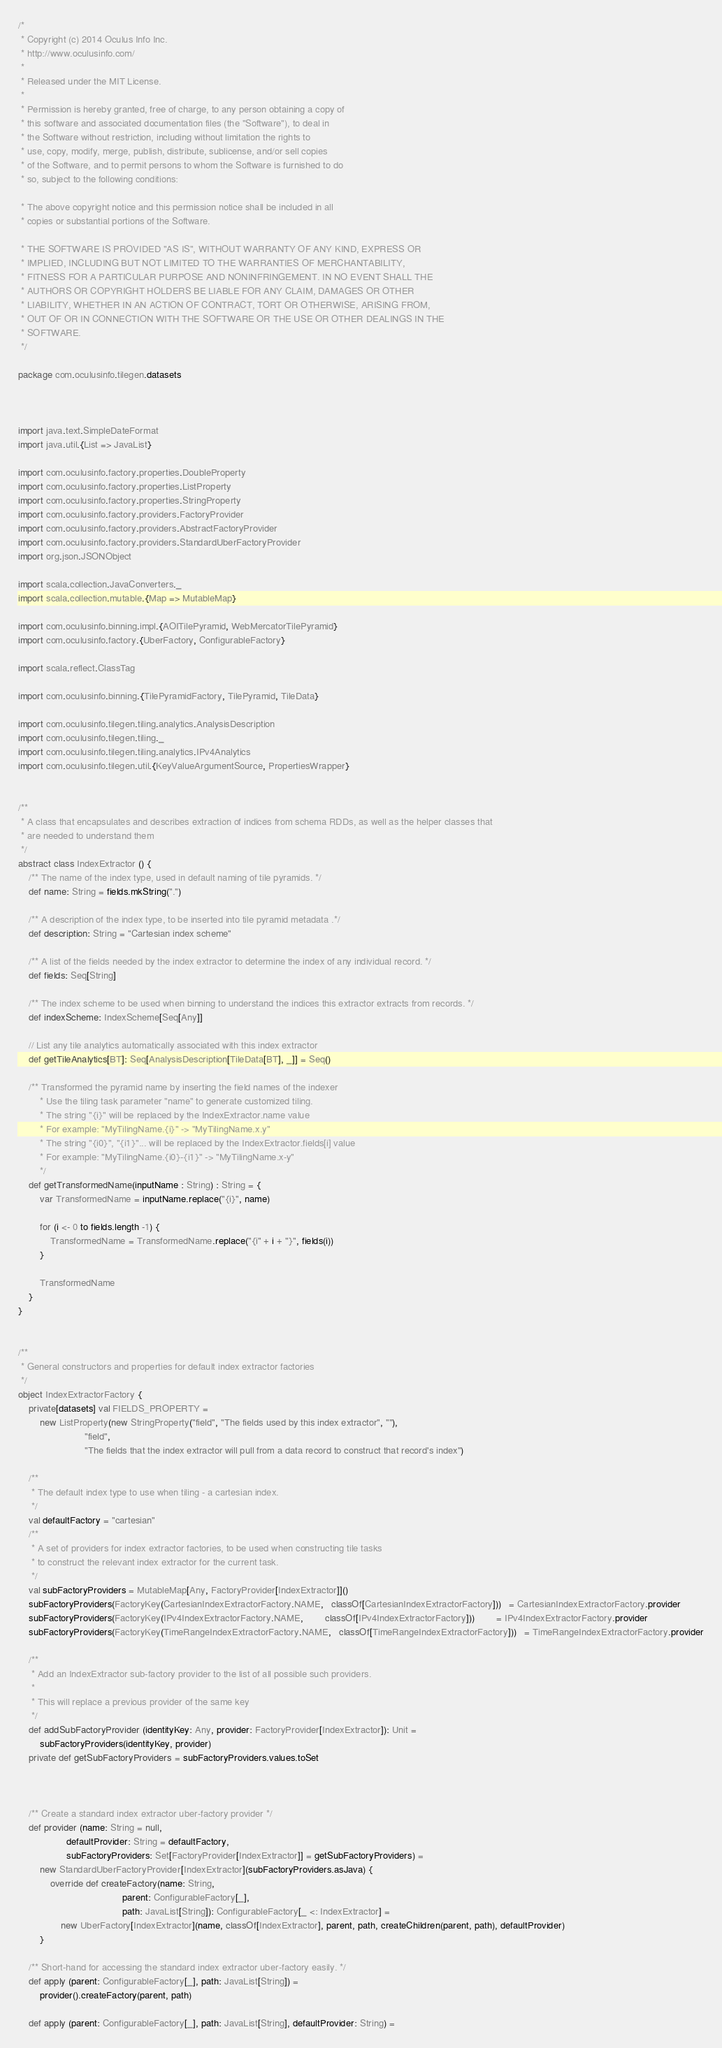Convert code to text. <code><loc_0><loc_0><loc_500><loc_500><_Scala_>/*
 * Copyright (c) 2014 Oculus Info Inc.
 * http://www.oculusinfo.com/
 *
 * Released under the MIT License.
 *
 * Permission is hereby granted, free of charge, to any person obtaining a copy of
 * this software and associated documentation files (the "Software"), to deal in
 * the Software without restriction, including without limitation the rights to
 * use, copy, modify, merge, publish, distribute, sublicense, and/or sell copies
 * of the Software, and to permit persons to whom the Software is furnished to do
 * so, subject to the following conditions:

 * The above copyright notice and this permission notice shall be included in all
 * copies or substantial portions of the Software.

 * THE SOFTWARE IS PROVIDED "AS IS", WITHOUT WARRANTY OF ANY KIND, EXPRESS OR
 * IMPLIED, INCLUDING BUT NOT LIMITED TO THE WARRANTIES OF MERCHANTABILITY,
 * FITNESS FOR A PARTICULAR PURPOSE AND NONINFRINGEMENT. IN NO EVENT SHALL THE
 * AUTHORS OR COPYRIGHT HOLDERS BE LIABLE FOR ANY CLAIM, DAMAGES OR OTHER
 * LIABILITY, WHETHER IN AN ACTION OF CONTRACT, TORT OR OTHERWISE, ARISING FROM,
 * OUT OF OR IN CONNECTION WITH THE SOFTWARE OR THE USE OR OTHER DEALINGS IN THE
 * SOFTWARE.
 */

package com.oculusinfo.tilegen.datasets



import java.text.SimpleDateFormat
import java.util.{List => JavaList}

import com.oculusinfo.factory.properties.DoubleProperty
import com.oculusinfo.factory.properties.ListProperty
import com.oculusinfo.factory.properties.StringProperty
import com.oculusinfo.factory.providers.FactoryProvider
import com.oculusinfo.factory.providers.AbstractFactoryProvider
import com.oculusinfo.factory.providers.StandardUberFactoryProvider
import org.json.JSONObject

import scala.collection.JavaConverters._
import scala.collection.mutable.{Map => MutableMap}

import com.oculusinfo.binning.impl.{AOITilePyramid, WebMercatorTilePyramid}
import com.oculusinfo.factory.{UberFactory, ConfigurableFactory}

import scala.reflect.ClassTag

import com.oculusinfo.binning.{TilePyramidFactory, TilePyramid, TileData}

import com.oculusinfo.tilegen.tiling.analytics.AnalysisDescription
import com.oculusinfo.tilegen.tiling._
import com.oculusinfo.tilegen.tiling.analytics.IPv4Analytics
import com.oculusinfo.tilegen.util.{KeyValueArgumentSource, PropertiesWrapper}


/**
 * A class that encapsulates and describes extraction of indices from schema RDDs, as well as the helper classes that
 * are needed to understand them
 */
abstract class IndexExtractor () {
	/** The name of the index type, used in default naming of tile pyramids. */
	def name: String = fields.mkString(".")

	/** A description of the index type, to be inserted into tile pyramid metadata .*/
	def description: String = "Cartesian index scheme"

	/** A list of the fields needed by the index extractor to determine the index of any individual record. */
	def fields: Seq[String]

	/** The index scheme to be used when binning to understand the indices this extractor extracts from records. */
	def indexScheme: IndexScheme[Seq[Any]]

	// List any tile analytics automatically associated with this index extractor
	def getTileAnalytics[BT]: Seq[AnalysisDescription[TileData[BT], _]] = Seq()

	/** Transformed the pyramid name by inserting the field names of the indexer
		* Use the tiling task parameter "name" to generate customized tiling.
		* The string "{i}" will be replaced by the IndexExtractor.name value
		* For example: "MyTilingName.{i}" -> "MyTilingName.x.y"
		* The string "{i0}", "{i1}"... will be replaced by the IndexExtractor.fields[i] value
		* For example: "MyTilingName.{i0}-{i1}" -> "MyTilingName.x-y"
		*/
	def getTransformedName(inputName : String) : String = {
		var TransformedName = inputName.replace("{i}", name)

		for (i <- 0 to fields.length -1) {
			TransformedName = TransformedName.replace("{i" + i + "}", fields(i))
		}
		
		TransformedName
	}
}


/**
 * General constructors and properties for default index extractor factories
 */
object IndexExtractorFactory {
	private[datasets] val FIELDS_PROPERTY =
		new ListProperty(new StringProperty("field", "The fields used by this index extractor", ""),
		                 "field",
		                 "The fields that the index extractor will pull from a data record to construct that record's index")

	/**
	 * The default index type to use when tiling - a cartesian index.
	 */
	val defaultFactory = "cartesian"
	/**
	 * A set of providers for index extractor factories, to be used when constructing tile tasks
	 * to construct the relevant index extractor for the current task.
	 */
	val subFactoryProviders = MutableMap[Any, FactoryProvider[IndexExtractor]]()
	subFactoryProviders(FactoryKey(CartesianIndexExtractorFactory.NAME,   classOf[CartesianIndexExtractorFactory]))   = CartesianIndexExtractorFactory.provider
	subFactoryProviders(FactoryKey(IPv4IndexExtractorFactory.NAME,        classOf[IPv4IndexExtractorFactory]))        = IPv4IndexExtractorFactory.provider
	subFactoryProviders(FactoryKey(TimeRangeIndexExtractorFactory.NAME,   classOf[TimeRangeIndexExtractorFactory]))   = TimeRangeIndexExtractorFactory.provider

	/**
	 * Add an IndexExtractor sub-factory provider to the list of all possible such providers.
	 *
	 * This will replace a previous provider of the same key
	 */
	def addSubFactoryProvider (identityKey: Any, provider: FactoryProvider[IndexExtractor]): Unit =
		subFactoryProviders(identityKey, provider)
	private def getSubFactoryProviders = subFactoryProviders.values.toSet



	/** Create a standard index extractor uber-factory provider */
	def provider (name: String = null,
	              defaultProvider: String = defaultFactory,
	              subFactoryProviders: Set[FactoryProvider[IndexExtractor]] = getSubFactoryProviders) =
		new StandardUberFactoryProvider[IndexExtractor](subFactoryProviders.asJava) {
			override def createFactory(name: String,
			                           parent: ConfigurableFactory[_],
			                           path: JavaList[String]): ConfigurableFactory[_ <: IndexExtractor] =
				new UberFactory[IndexExtractor](name, classOf[IndexExtractor], parent, path, createChildren(parent, path), defaultProvider)
		}

	/** Short-hand for accessing the standard index extractor uber-factory easily. */
	def apply (parent: ConfigurableFactory[_], path: JavaList[String]) =
		provider().createFactory(parent, path)

	def apply (parent: ConfigurableFactory[_], path: JavaList[String], defaultProvider: String) =</code> 